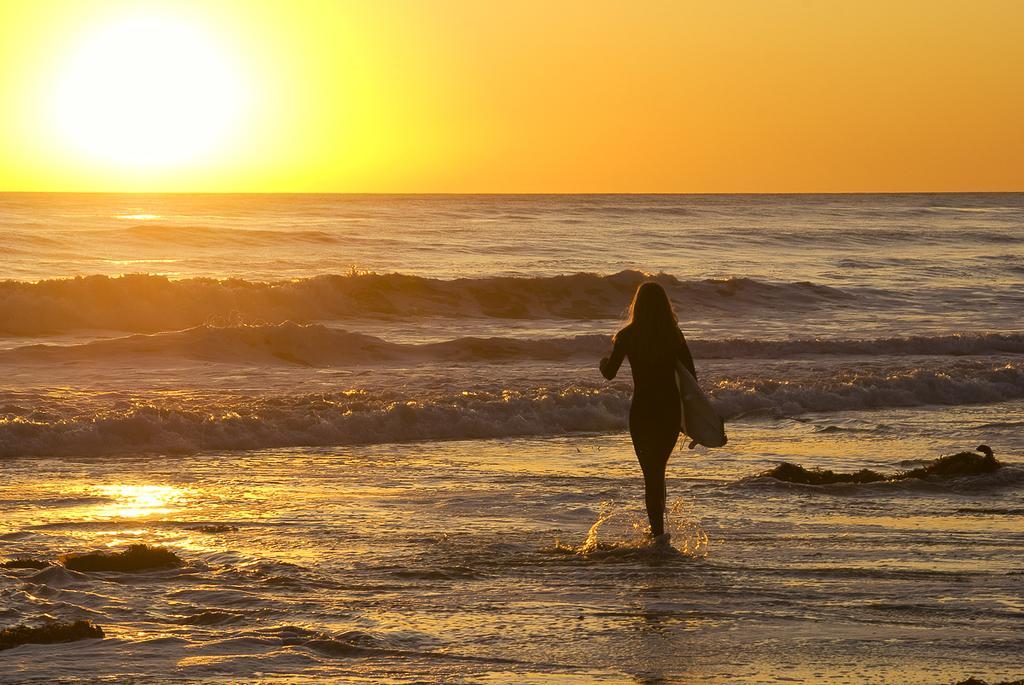How would you summarize this image in a sentence or two? This image consist of a beach. There is woman walking and holding a surfboard in her hand. In the background there is sky. At the bottom, there is water. 